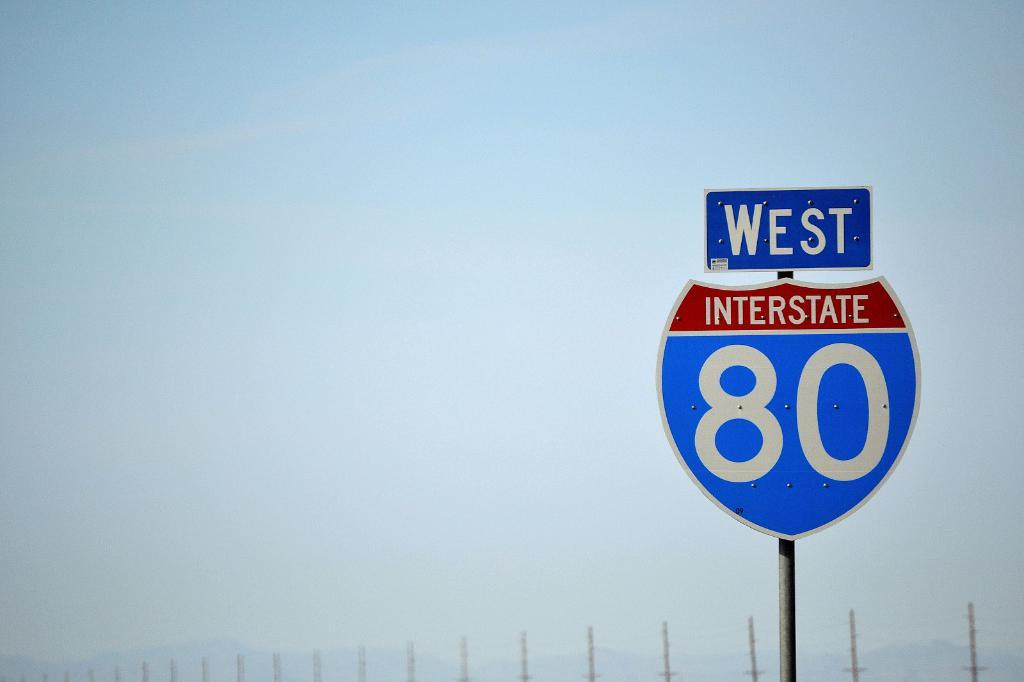<image>
Give a short and clear explanation of the subsequent image. west interstate 80 sign on an overcast day 